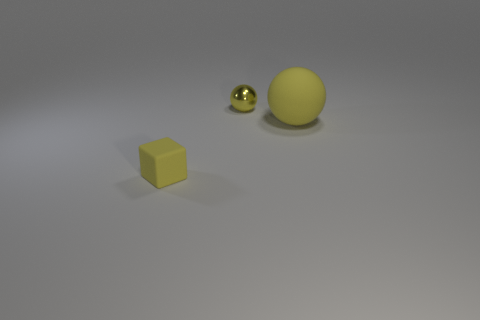Add 2 yellow blocks. How many objects exist? 5 Subtract all balls. How many objects are left? 1 Add 2 yellow shiny balls. How many yellow shiny balls are left? 3 Add 1 matte cubes. How many matte cubes exist? 2 Subtract 0 red cubes. How many objects are left? 3 Subtract all big yellow rubber balls. Subtract all tiny gray cylinders. How many objects are left? 2 